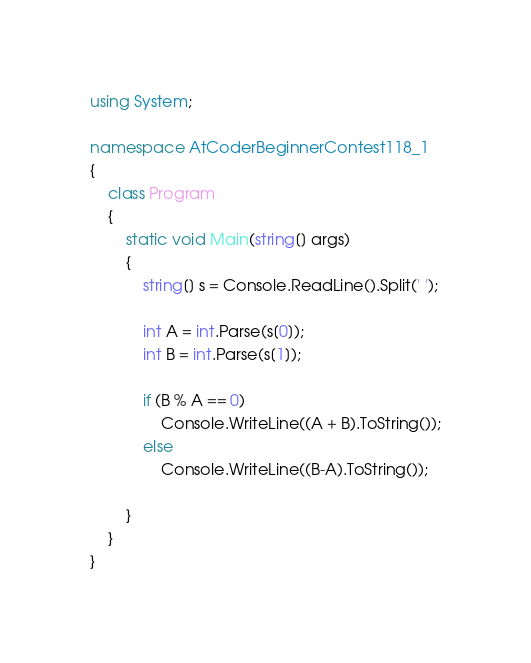<code> <loc_0><loc_0><loc_500><loc_500><_C#_>using System;

namespace AtCoderBeginnerContest118_1
{
    class Program
    {
        static void Main(string[] args)
        {
            string[] s = Console.ReadLine().Split(' ');

            int A = int.Parse(s[0]);
            int B = int.Parse(s[1]);

            if (B % A == 0)
                Console.WriteLine((A + B).ToString());
            else
                Console.WriteLine((B-A).ToString());

        }
    }
}
</code> 